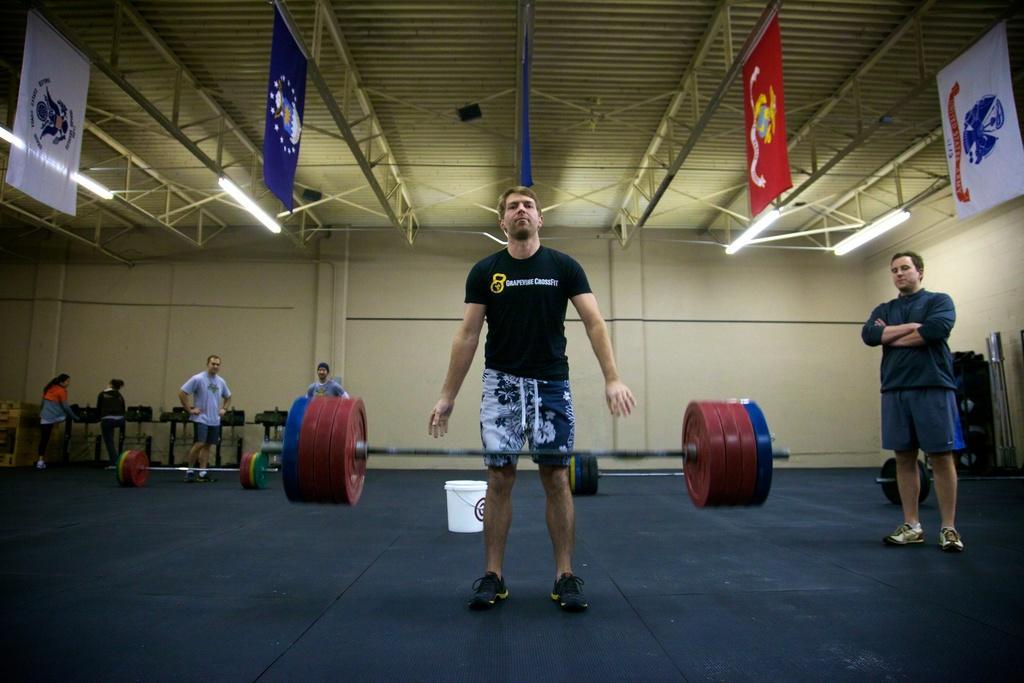Can you describe this image briefly? In the picture we can see some persons standing in a closed auditorium and there are some weights and in the background there is wall, top of the picture there is roof, there are some lights, flags. 